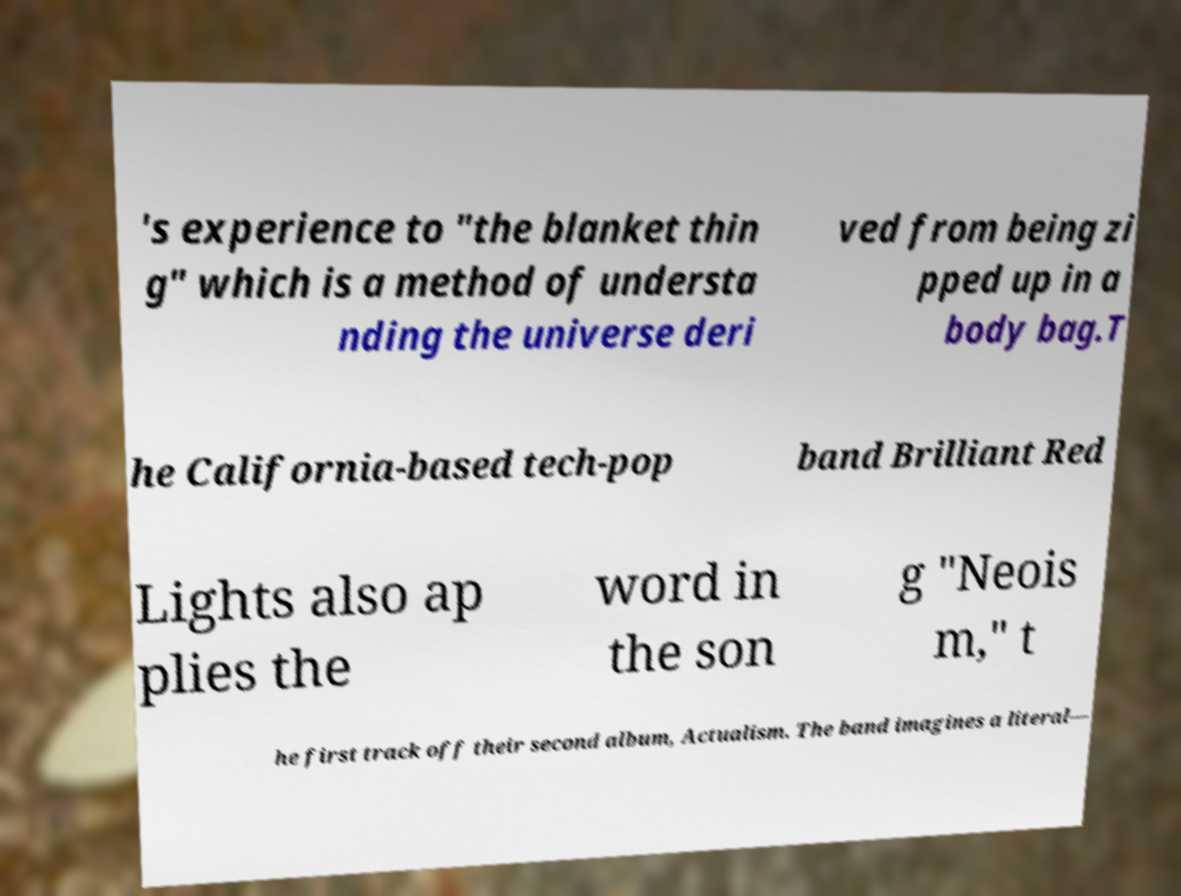Could you extract and type out the text from this image? 's experience to "the blanket thin g" which is a method of understa nding the universe deri ved from being zi pped up in a body bag.T he California-based tech-pop band Brilliant Red Lights also ap plies the word in the son g "Neois m," t he first track off their second album, Actualism. The band imagines a literal— 